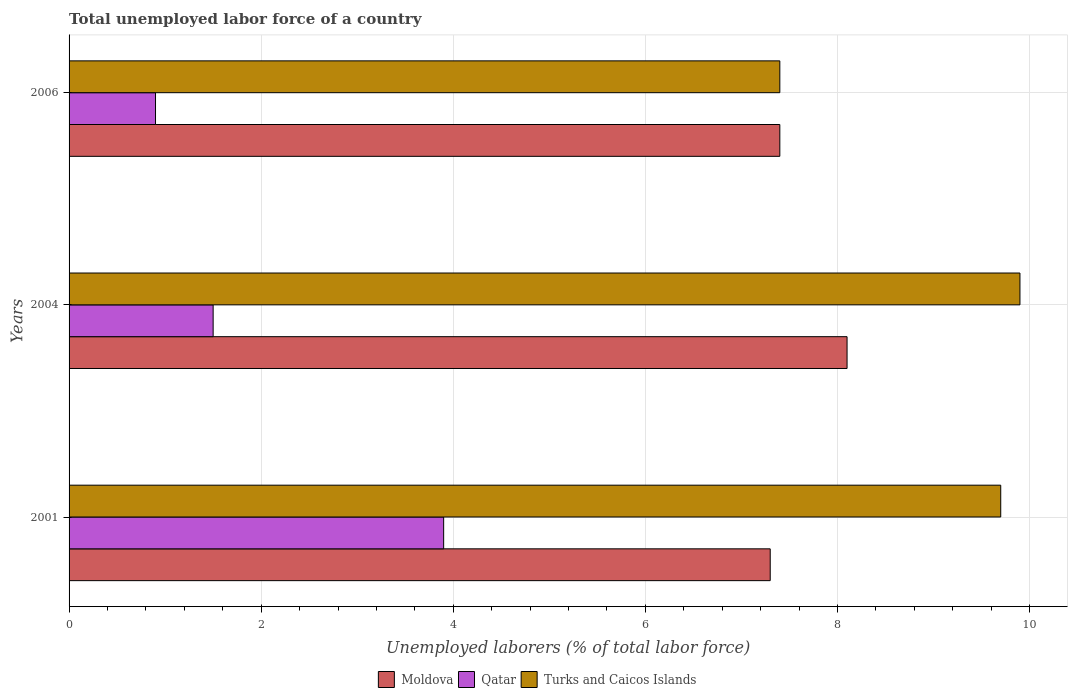How many different coloured bars are there?
Offer a terse response. 3. How many groups of bars are there?
Offer a very short reply. 3. How many bars are there on the 2nd tick from the top?
Your answer should be compact. 3. What is the label of the 1st group of bars from the top?
Your answer should be very brief. 2006. In how many cases, is the number of bars for a given year not equal to the number of legend labels?
Give a very brief answer. 0. What is the total unemployed labor force in Qatar in 2001?
Keep it short and to the point. 3.9. Across all years, what is the maximum total unemployed labor force in Moldova?
Ensure brevity in your answer.  8.1. Across all years, what is the minimum total unemployed labor force in Turks and Caicos Islands?
Provide a succinct answer. 7.4. In which year was the total unemployed labor force in Moldova maximum?
Keep it short and to the point. 2004. In which year was the total unemployed labor force in Moldova minimum?
Your answer should be very brief. 2001. What is the total total unemployed labor force in Qatar in the graph?
Your response must be concise. 6.3. What is the difference between the total unemployed labor force in Turks and Caicos Islands in 2004 and that in 2006?
Offer a terse response. 2.5. What is the difference between the total unemployed labor force in Qatar in 2004 and the total unemployed labor force in Moldova in 2001?
Your response must be concise. -5.8. What is the average total unemployed labor force in Qatar per year?
Offer a very short reply. 2.1. In the year 2001, what is the difference between the total unemployed labor force in Turks and Caicos Islands and total unemployed labor force in Moldova?
Give a very brief answer. 2.4. What is the ratio of the total unemployed labor force in Turks and Caicos Islands in 2004 to that in 2006?
Give a very brief answer. 1.34. Is the difference between the total unemployed labor force in Turks and Caicos Islands in 2001 and 2004 greater than the difference between the total unemployed labor force in Moldova in 2001 and 2004?
Ensure brevity in your answer.  Yes. What is the difference between the highest and the second highest total unemployed labor force in Moldova?
Your answer should be compact. 0.7. What is the difference between the highest and the lowest total unemployed labor force in Qatar?
Offer a very short reply. 3. What does the 3rd bar from the top in 2004 represents?
Your response must be concise. Moldova. What does the 2nd bar from the bottom in 2001 represents?
Provide a short and direct response. Qatar. How many bars are there?
Offer a very short reply. 9. Are all the bars in the graph horizontal?
Your answer should be compact. Yes. How many years are there in the graph?
Offer a terse response. 3. What is the difference between two consecutive major ticks on the X-axis?
Offer a terse response. 2. Does the graph contain grids?
Your answer should be compact. Yes. Where does the legend appear in the graph?
Your answer should be very brief. Bottom center. What is the title of the graph?
Offer a very short reply. Total unemployed labor force of a country. Does "Bhutan" appear as one of the legend labels in the graph?
Ensure brevity in your answer.  No. What is the label or title of the X-axis?
Your answer should be compact. Unemployed laborers (% of total labor force). What is the Unemployed laborers (% of total labor force) of Moldova in 2001?
Your answer should be very brief. 7.3. What is the Unemployed laborers (% of total labor force) of Qatar in 2001?
Offer a very short reply. 3.9. What is the Unemployed laborers (% of total labor force) of Turks and Caicos Islands in 2001?
Keep it short and to the point. 9.7. What is the Unemployed laborers (% of total labor force) in Moldova in 2004?
Your answer should be compact. 8.1. What is the Unemployed laborers (% of total labor force) in Turks and Caicos Islands in 2004?
Your answer should be very brief. 9.9. What is the Unemployed laborers (% of total labor force) of Moldova in 2006?
Your answer should be very brief. 7.4. What is the Unemployed laborers (% of total labor force) of Qatar in 2006?
Keep it short and to the point. 0.9. What is the Unemployed laborers (% of total labor force) of Turks and Caicos Islands in 2006?
Provide a succinct answer. 7.4. Across all years, what is the maximum Unemployed laborers (% of total labor force) in Moldova?
Keep it short and to the point. 8.1. Across all years, what is the maximum Unemployed laborers (% of total labor force) of Qatar?
Your answer should be very brief. 3.9. Across all years, what is the maximum Unemployed laborers (% of total labor force) of Turks and Caicos Islands?
Keep it short and to the point. 9.9. Across all years, what is the minimum Unemployed laborers (% of total labor force) of Moldova?
Provide a short and direct response. 7.3. Across all years, what is the minimum Unemployed laborers (% of total labor force) of Qatar?
Offer a terse response. 0.9. Across all years, what is the minimum Unemployed laborers (% of total labor force) in Turks and Caicos Islands?
Make the answer very short. 7.4. What is the total Unemployed laborers (% of total labor force) in Moldova in the graph?
Your answer should be compact. 22.8. What is the total Unemployed laborers (% of total labor force) in Turks and Caicos Islands in the graph?
Make the answer very short. 27. What is the difference between the Unemployed laborers (% of total labor force) in Moldova in 2001 and that in 2004?
Offer a very short reply. -0.8. What is the difference between the Unemployed laborers (% of total labor force) of Qatar in 2001 and that in 2004?
Your answer should be compact. 2.4. What is the difference between the Unemployed laborers (% of total labor force) of Moldova in 2001 and that in 2006?
Make the answer very short. -0.1. What is the difference between the Unemployed laborers (% of total labor force) of Turks and Caicos Islands in 2001 and that in 2006?
Give a very brief answer. 2.3. What is the difference between the Unemployed laborers (% of total labor force) in Qatar in 2004 and that in 2006?
Keep it short and to the point. 0.6. What is the difference between the Unemployed laborers (% of total labor force) of Turks and Caicos Islands in 2004 and that in 2006?
Give a very brief answer. 2.5. What is the difference between the Unemployed laborers (% of total labor force) in Moldova in 2001 and the Unemployed laborers (% of total labor force) in Turks and Caicos Islands in 2004?
Give a very brief answer. -2.6. What is the difference between the Unemployed laborers (% of total labor force) of Moldova in 2004 and the Unemployed laborers (% of total labor force) of Qatar in 2006?
Provide a succinct answer. 7.2. What is the difference between the Unemployed laborers (% of total labor force) of Qatar in 2004 and the Unemployed laborers (% of total labor force) of Turks and Caicos Islands in 2006?
Ensure brevity in your answer.  -5.9. What is the average Unemployed laborers (% of total labor force) of Qatar per year?
Make the answer very short. 2.1. What is the average Unemployed laborers (% of total labor force) in Turks and Caicos Islands per year?
Give a very brief answer. 9. In the year 2001, what is the difference between the Unemployed laborers (% of total labor force) of Moldova and Unemployed laborers (% of total labor force) of Turks and Caicos Islands?
Ensure brevity in your answer.  -2.4. In the year 2001, what is the difference between the Unemployed laborers (% of total labor force) in Qatar and Unemployed laborers (% of total labor force) in Turks and Caicos Islands?
Ensure brevity in your answer.  -5.8. In the year 2004, what is the difference between the Unemployed laborers (% of total labor force) of Moldova and Unemployed laborers (% of total labor force) of Turks and Caicos Islands?
Provide a succinct answer. -1.8. In the year 2004, what is the difference between the Unemployed laborers (% of total labor force) in Qatar and Unemployed laborers (% of total labor force) in Turks and Caicos Islands?
Your answer should be compact. -8.4. In the year 2006, what is the difference between the Unemployed laborers (% of total labor force) of Moldova and Unemployed laborers (% of total labor force) of Qatar?
Offer a terse response. 6.5. What is the ratio of the Unemployed laborers (% of total labor force) in Moldova in 2001 to that in 2004?
Provide a short and direct response. 0.9. What is the ratio of the Unemployed laborers (% of total labor force) of Qatar in 2001 to that in 2004?
Keep it short and to the point. 2.6. What is the ratio of the Unemployed laborers (% of total labor force) of Turks and Caicos Islands in 2001 to that in 2004?
Offer a very short reply. 0.98. What is the ratio of the Unemployed laborers (% of total labor force) of Moldova in 2001 to that in 2006?
Your answer should be very brief. 0.99. What is the ratio of the Unemployed laborers (% of total labor force) in Qatar in 2001 to that in 2006?
Your answer should be compact. 4.33. What is the ratio of the Unemployed laborers (% of total labor force) in Turks and Caicos Islands in 2001 to that in 2006?
Your answer should be compact. 1.31. What is the ratio of the Unemployed laborers (% of total labor force) in Moldova in 2004 to that in 2006?
Provide a succinct answer. 1.09. What is the ratio of the Unemployed laborers (% of total labor force) of Turks and Caicos Islands in 2004 to that in 2006?
Your response must be concise. 1.34. What is the difference between the highest and the lowest Unemployed laborers (% of total labor force) of Moldova?
Offer a terse response. 0.8. What is the difference between the highest and the lowest Unemployed laborers (% of total labor force) in Qatar?
Your response must be concise. 3. What is the difference between the highest and the lowest Unemployed laborers (% of total labor force) in Turks and Caicos Islands?
Provide a short and direct response. 2.5. 